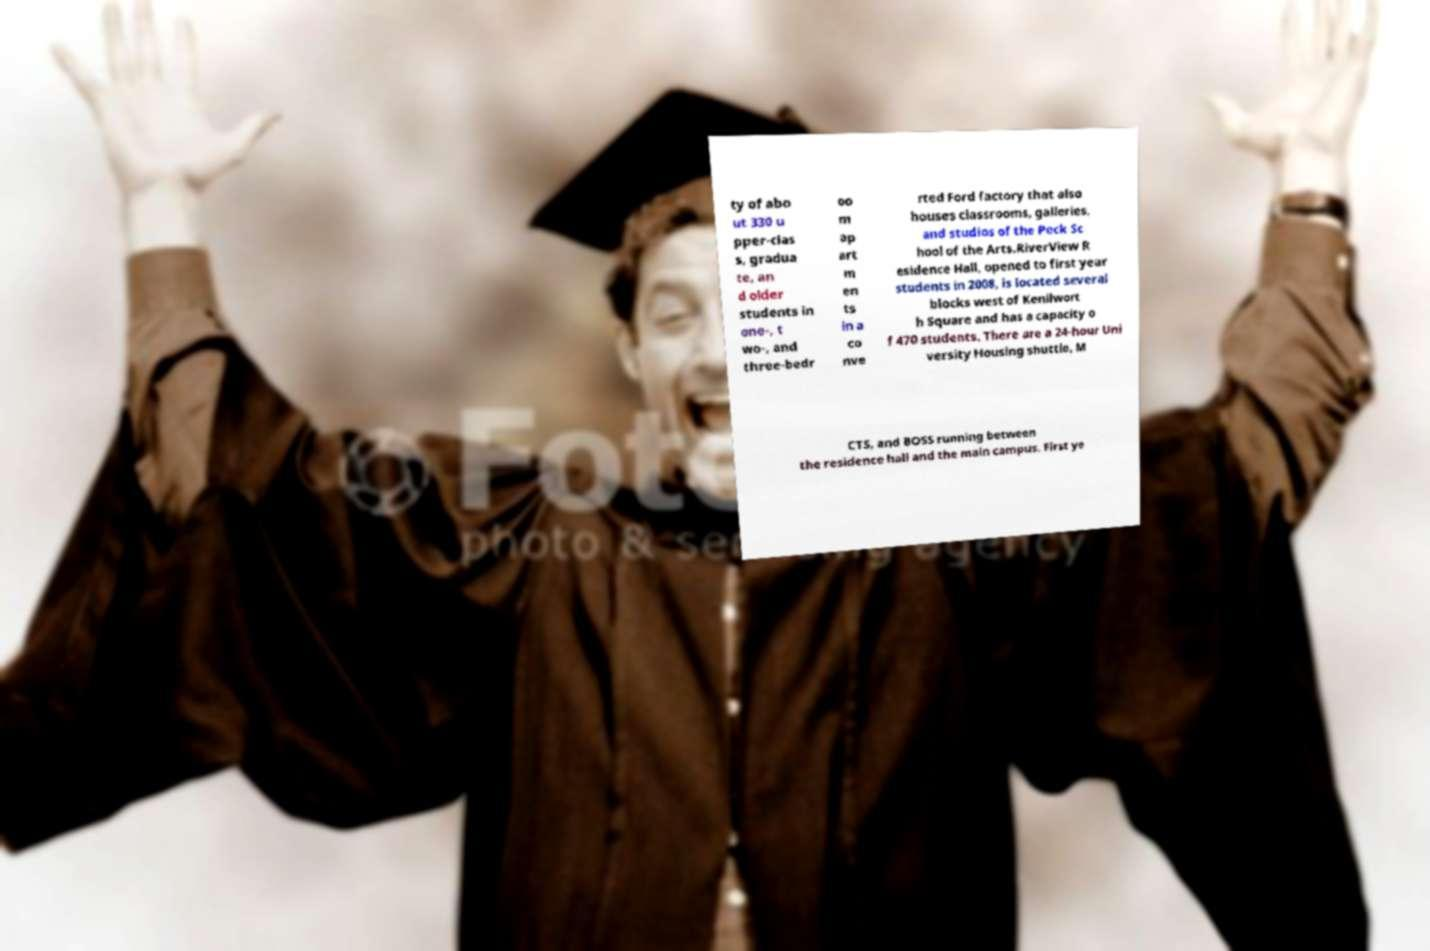I need the written content from this picture converted into text. Can you do that? ty of abo ut 330 u pper-clas s, gradua te, an d older students in one-, t wo-, and three-bedr oo m ap art m en ts in a co nve rted Ford factory that also houses classrooms, galleries, and studios of the Peck Sc hool of the Arts.RiverView R esidence Hall, opened to first year students in 2008, is located several blocks west of Kenilwort h Square and has a capacity o f 470 students. There are a 24-hour Uni versity Housing shuttle, M CTS, and BOSS running between the residence hall and the main campus. First ye 